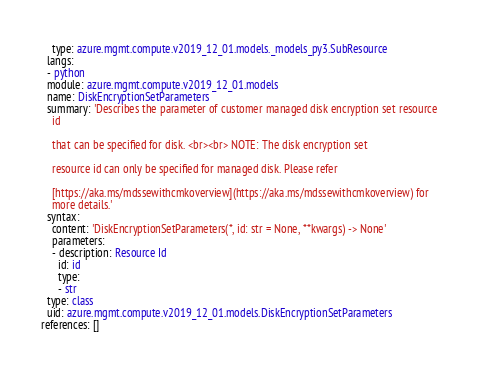Convert code to text. <code><loc_0><loc_0><loc_500><loc_500><_YAML_>    type: azure.mgmt.compute.v2019_12_01.models._models_py3.SubResource
  langs:
  - python
  module: azure.mgmt.compute.v2019_12_01.models
  name: DiskEncryptionSetParameters
  summary: 'Describes the parameter of customer managed disk encryption set resource
    id

    that can be specified for disk. <br><br> NOTE: The disk encryption set

    resource id can only be specified for managed disk. Please refer

    [https://aka.ms/mdssewithcmkoverview](https://aka.ms/mdssewithcmkoverview) for
    more details.'
  syntax:
    content: 'DiskEncryptionSetParameters(*, id: str = None, **kwargs) -> None'
    parameters:
    - description: Resource Id
      id: id
      type:
      - str
  type: class
  uid: azure.mgmt.compute.v2019_12_01.models.DiskEncryptionSetParameters
references: []
</code> 